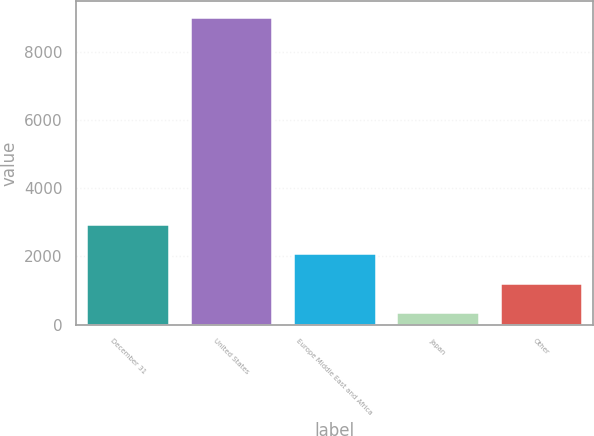<chart> <loc_0><loc_0><loc_500><loc_500><bar_chart><fcel>December 31<fcel>United States<fcel>Europe Middle East and Africa<fcel>Japan<fcel>Other<nl><fcel>2960.36<fcel>9023.2<fcel>2094.24<fcel>362<fcel>1228.12<nl></chart> 